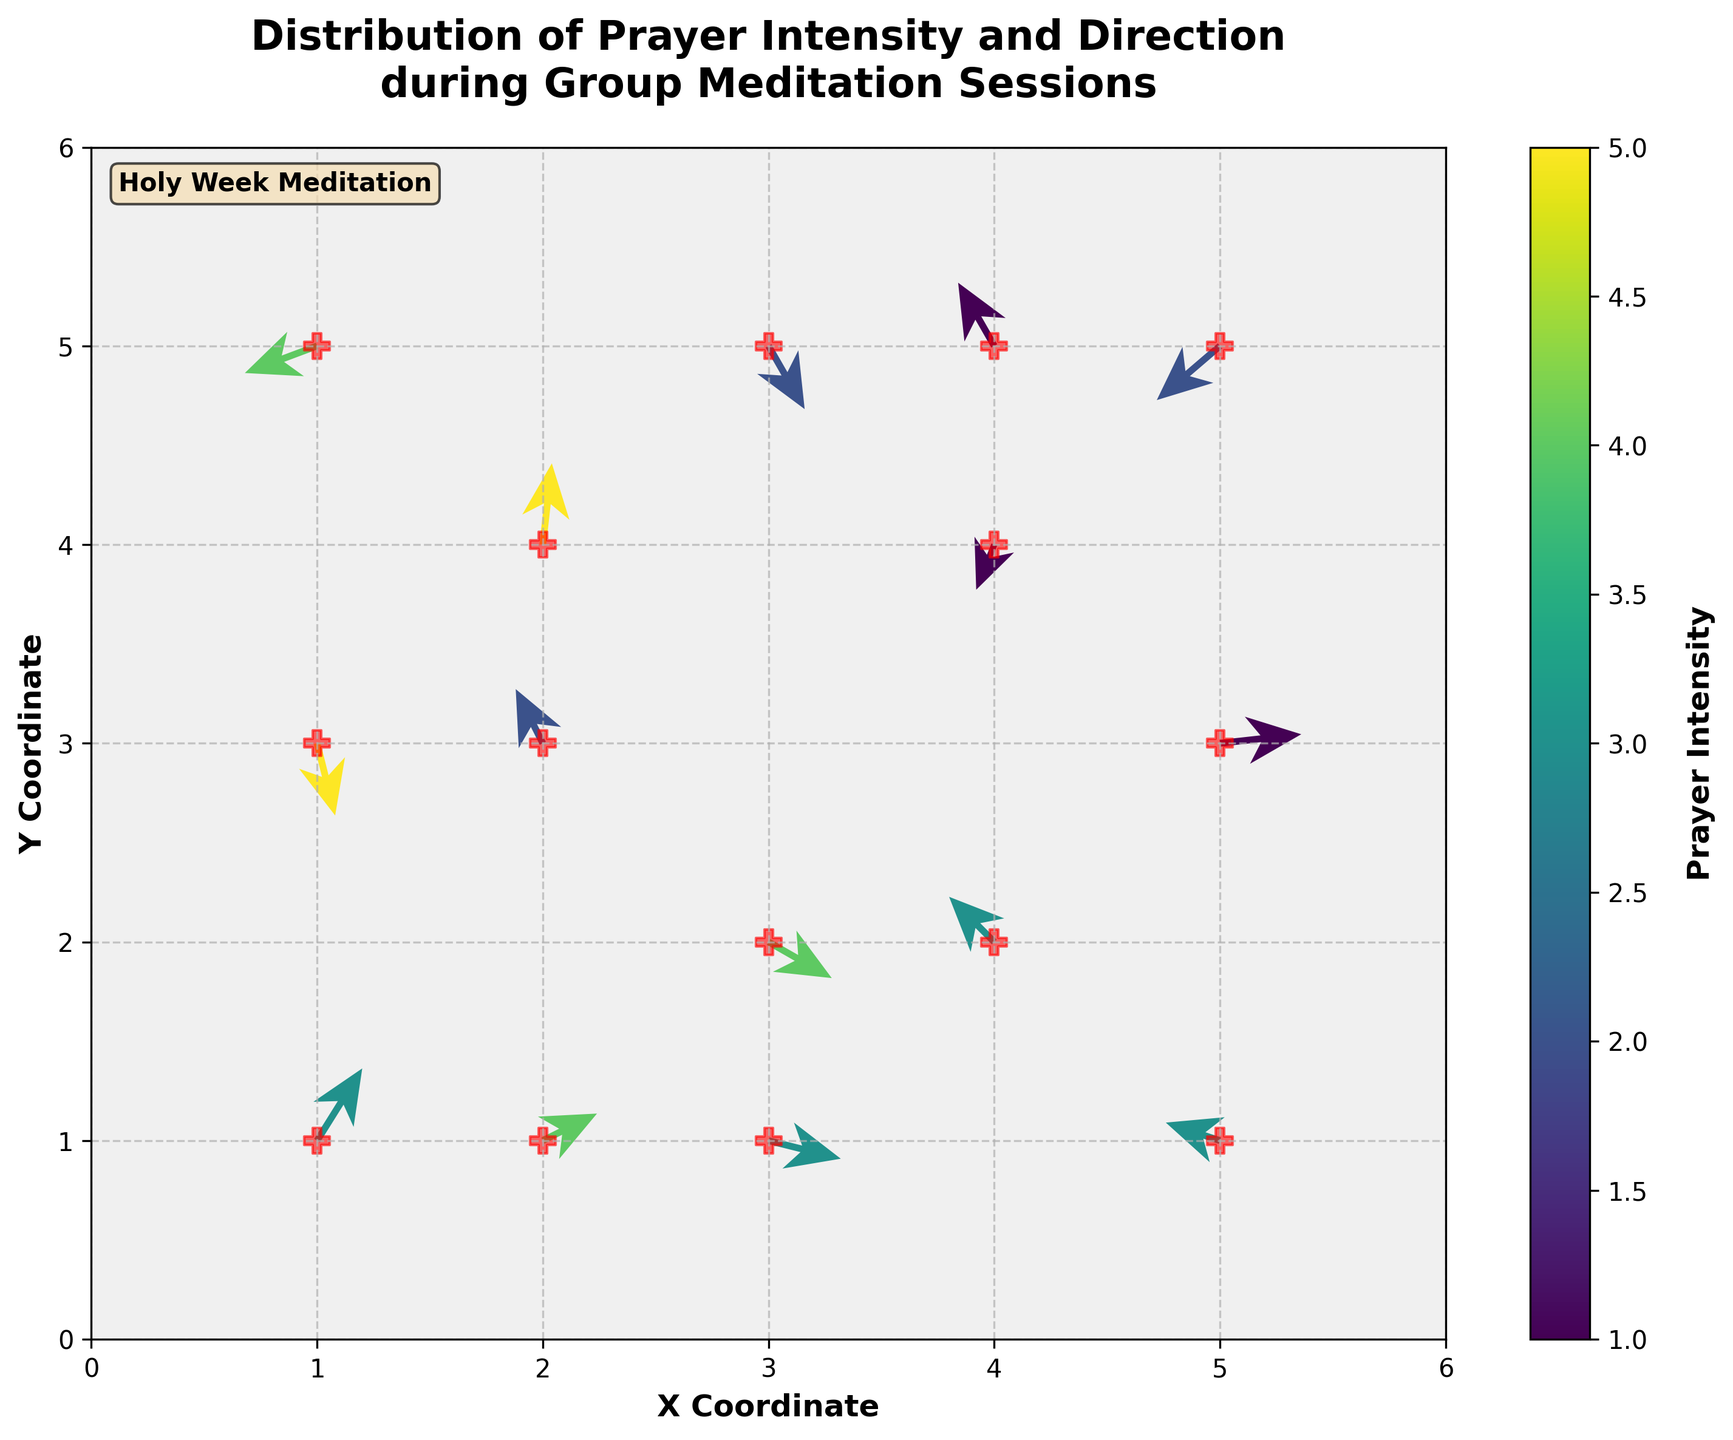What is the title of the figure? The title is located at the top of the figure and provides an overview of what the plot represents.
Answer: Distribution of Prayer Intensity and Direction during Group Meditation Sessions How many data points are represented in the plot? Count the number of arrows on the plot. Each arrow represents a data point.
Answer: 15 What color is associated with the highest prayer intensity? The colorbar on the right side of the plot indicates the color scale. The highest intensity is shown in a bright yellow color on the colorbar.
Answer: Bright yellow Which region has the densest concentration of prayer direction arrows? Look at the areas on the plot where arrows are closely clustered together. The central region around coordinates (2,3) to (4,4) has a dense concentration of arrows.
Answer: The central region around coordinates (2,3) to (4,4) In which quadrant of the plot do we see the most significant negative prayer directions (those pointing to the left and downward)? Observe the direction of the arrows. Negative directions have negative values for both u and v components, represented by arrows pointing left and down.
Answer: Bottom-left quadrant What is the prayer intensity at the point (4, 5)? Locate the arrow at the coordinate (4, 5) and refer to the colorbar to find the corresponding color intensity. The arrow at (4, 5) has a lower intensity, correlated with a darker color.
Answer: 1 Which data point has the largest upward direction? Find the arrow with the longest upward tail. This corresponds to the highest positive v value. The arrow at (2, 4) points significantly upward.
Answer: (2, 4) Compare the prayer directions at (1, 5) and (3, 5). Which one is pointing more downward? Look at the arrows at (1, 5) and (3, 5). The arrow at (1, 5) with a more negative v value points more downward compared to (3, 5).
Answer: (1, 5) Which data points have their total direction vectors (u, v) whose lengths are roughly equal? Calculate the magnitude of the vectors √(u² + v²) for each data point and compare. For example, at (1, 1) and (4, 2), both have similar magnitudes of their direction vectors.
Answer: (1, 1) and (4, 2) What is the prayer intensity of the middle data point in the list? Reference the order of data points and identify the middle one, which is the 8th point. The intensity of the middle data point can be located at (1, 5) with an intensity of 4.
Answer: 4 